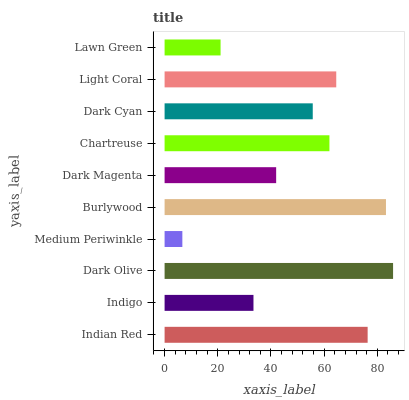Is Medium Periwinkle the minimum?
Answer yes or no. Yes. Is Dark Olive the maximum?
Answer yes or no. Yes. Is Indigo the minimum?
Answer yes or no. No. Is Indigo the maximum?
Answer yes or no. No. Is Indian Red greater than Indigo?
Answer yes or no. Yes. Is Indigo less than Indian Red?
Answer yes or no. Yes. Is Indigo greater than Indian Red?
Answer yes or no. No. Is Indian Red less than Indigo?
Answer yes or no. No. Is Chartreuse the high median?
Answer yes or no. Yes. Is Dark Cyan the low median?
Answer yes or no. Yes. Is Light Coral the high median?
Answer yes or no. No. Is Chartreuse the low median?
Answer yes or no. No. 